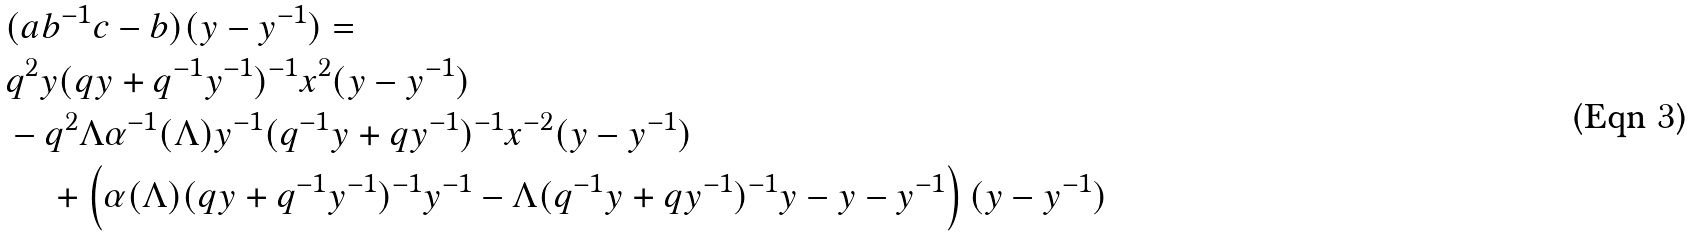Convert formula to latex. <formula><loc_0><loc_0><loc_500><loc_500>& ( a b ^ { - 1 } c - b ) ( y - y ^ { - 1 } ) = \\ & q ^ { 2 } y ( q y + q ^ { - 1 } y ^ { - 1 } ) ^ { - 1 } x ^ { 2 } ( y - y ^ { - 1 } ) \\ & - q ^ { 2 } \Lambda \alpha ^ { - 1 } ( \Lambda ) y ^ { - 1 } ( q ^ { - 1 } y + q y ^ { - 1 } ) ^ { - 1 } x ^ { - 2 } ( y - y ^ { - 1 } ) \\ & \, \quad + \left ( \alpha ( \Lambda ) ( q y + q ^ { - 1 } y ^ { - 1 } ) ^ { - 1 } y ^ { - 1 } - \Lambda ( q ^ { - 1 } y + q y ^ { - 1 } ) ^ { - 1 } y - y - y ^ { - 1 } \right ) ( y - y ^ { - 1 } ) \\</formula> 